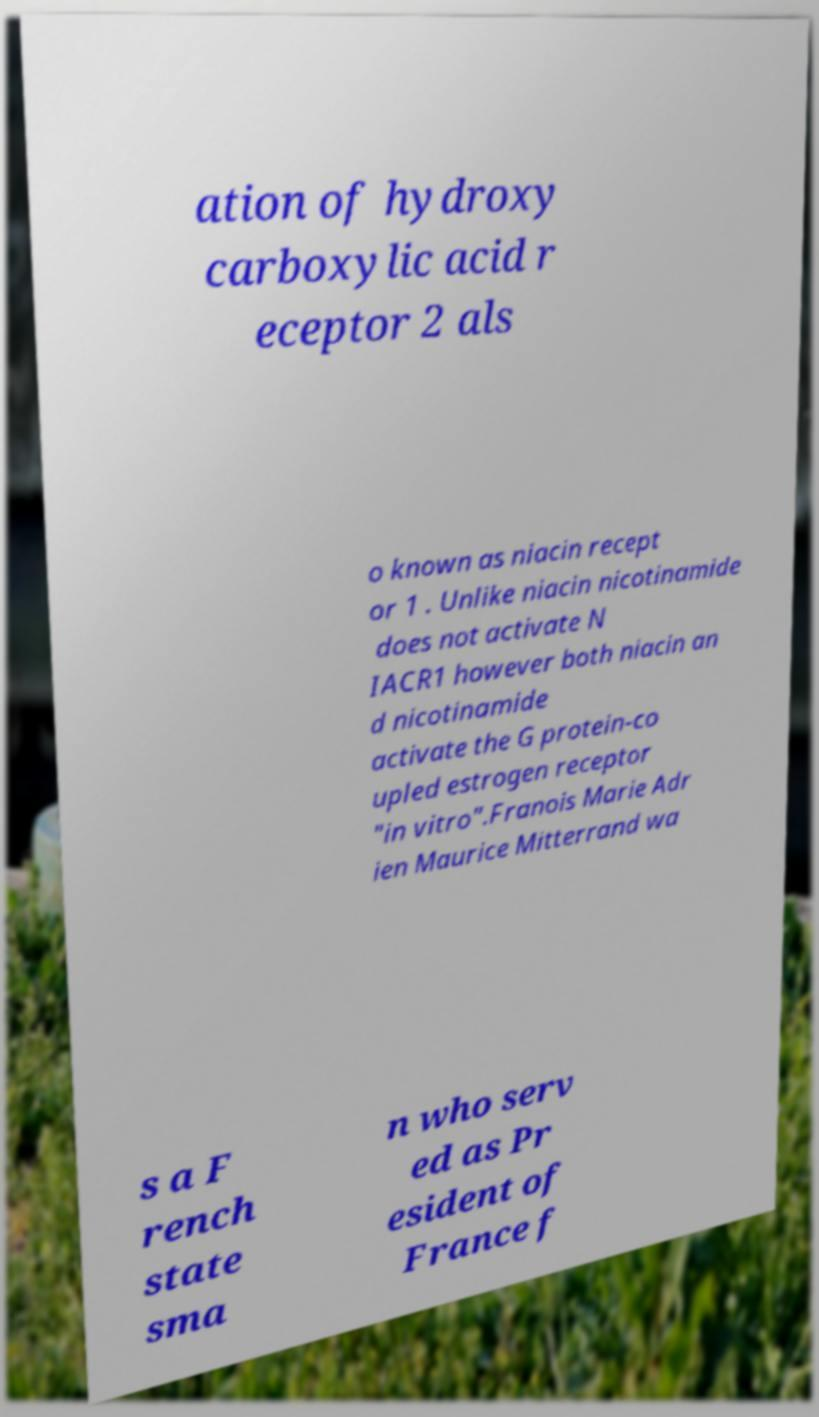Please identify and transcribe the text found in this image. ation of hydroxy carboxylic acid r eceptor 2 als o known as niacin recept or 1 . Unlike niacin nicotinamide does not activate N IACR1 however both niacin an d nicotinamide activate the G protein-co upled estrogen receptor "in vitro".Franois Marie Adr ien Maurice Mitterrand wa s a F rench state sma n who serv ed as Pr esident of France f 